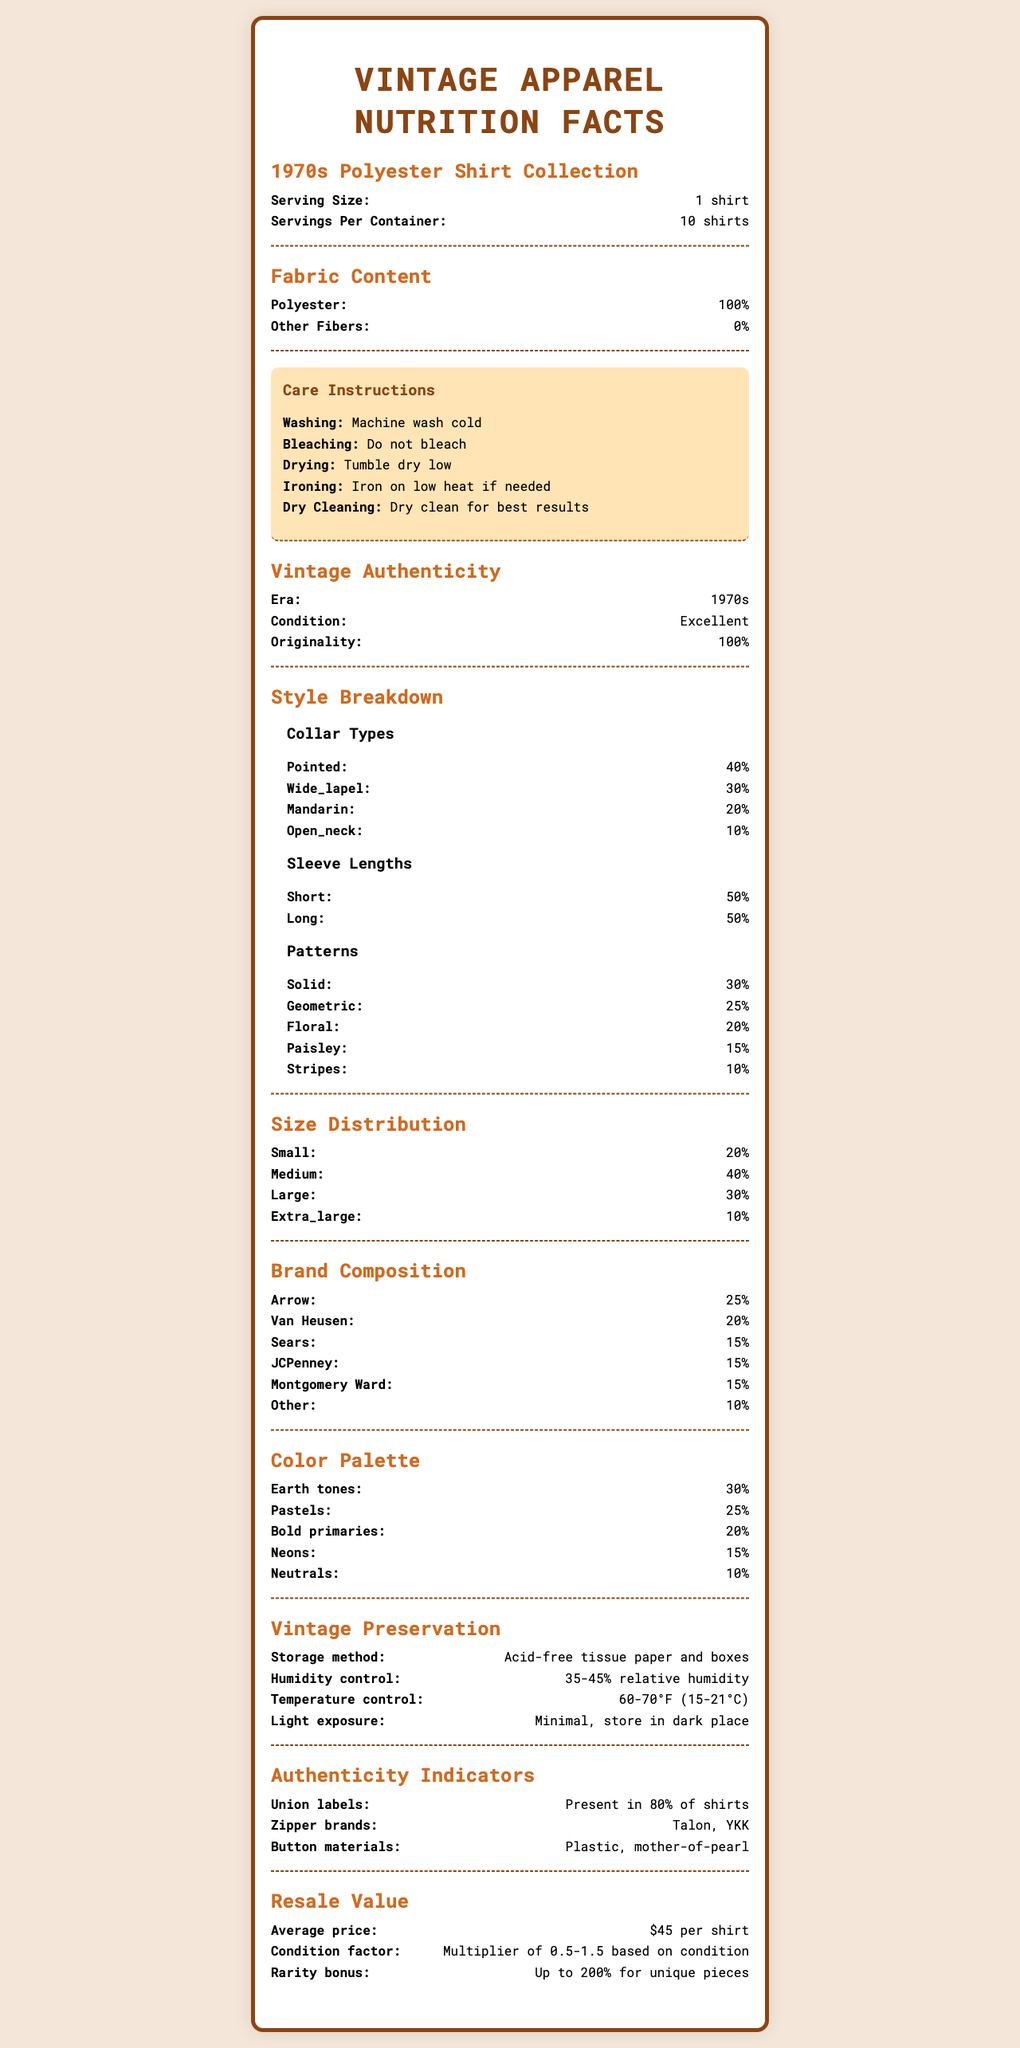what is the serving size of the 1970s Polyester Shirt Collection? The document states the serving size as "1 shirt".
Answer: 1 shirt how should you wash the 1970s Polyester Shirt Collection? The care instructions section lists "Machine wash cold" for washing.
Answer: Machine wash cold which collar type is the most common in the collection? The style breakdown section shows pointed collars make up 40% of the collection, which is the highest.
Answer: Pointed what percentage of the shirts are made of polyester? The fabric content section clearly states that the polyester content is 100%.
Answer: 100% how should you store the shirts to preserve their vintage condition? The vintage preservation section specifies the storage method as "Acid-free tissue paper and boxes".
Answer: Acid-free tissue paper and boxes which sleeve length is equally distributed in the 1970s Polyester Shirt Collection? A. Short B. Long C. Both The style breakdown section indicates both short sleeves and long sleeves each make up 50% of the collection.
Answer: C what should be avoided during the bleaching of the shirts? A: Bleach B: Ironing C: Dry cleaning D: Machine washing The care instructions specify "Do not bleach".
Answer: A is dry cleaning recommended for the best results? The care instructions state "Dry clean for best results".
Answer: Yes summarize the main idea of the document. The document features sections detailing various aspects of the apparel collection, including its composition, care, authenticity, style, and value.
Answer: The document provides detailed information about a collection of 1970s polyester shirts, including fabric content, care instructions, vintage authenticity, style breakdown, size distribution, brand composition, color palette, preservation methods, authenticity indicators, and resale value. how many brands are included in the 1970s Polyester Shirt Collection? The document provides the composition percentages for brands but does not specify the total number of distinct brands.
Answer: Cannot be determined what percentage of the collection consists of Arrow branded shirts? The brand composition section indicates that Arrow contributes 25% to the collection.
Answer: 25% what are the recommended conditions for humidity control in the preservation of the shirts? The vintage preservation section states the recommended humidity control as "35-45% relative humidity".
Answer: 35-45% relative humidity 